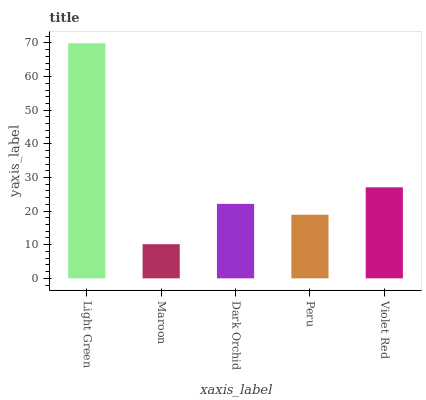Is Maroon the minimum?
Answer yes or no. Yes. Is Light Green the maximum?
Answer yes or no. Yes. Is Dark Orchid the minimum?
Answer yes or no. No. Is Dark Orchid the maximum?
Answer yes or no. No. Is Dark Orchid greater than Maroon?
Answer yes or no. Yes. Is Maroon less than Dark Orchid?
Answer yes or no. Yes. Is Maroon greater than Dark Orchid?
Answer yes or no. No. Is Dark Orchid less than Maroon?
Answer yes or no. No. Is Dark Orchid the high median?
Answer yes or no. Yes. Is Dark Orchid the low median?
Answer yes or no. Yes. Is Peru the high median?
Answer yes or no. No. Is Violet Red the low median?
Answer yes or no. No. 